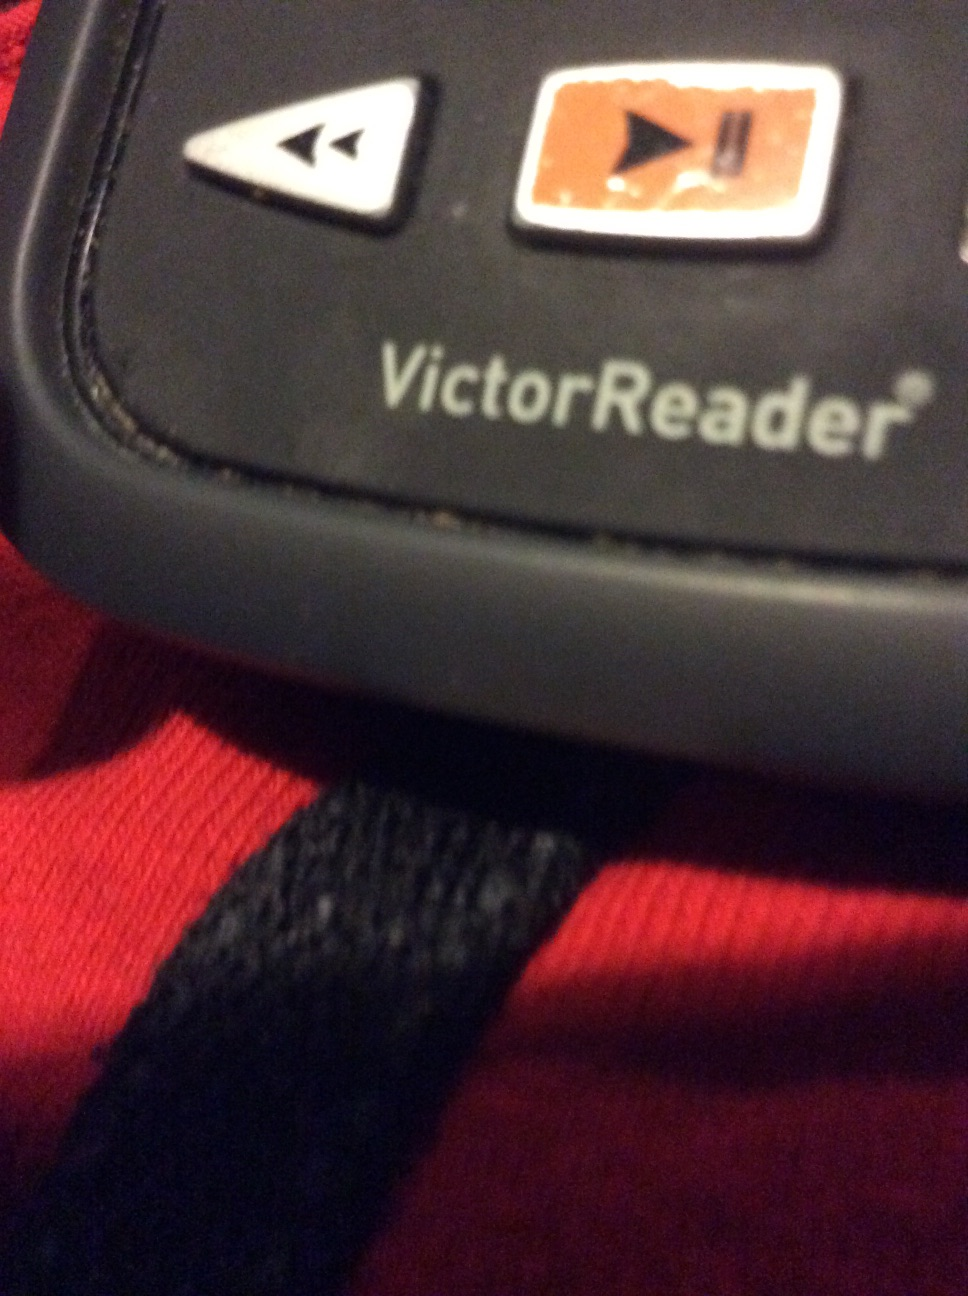Imagine a world where VictorReader devices are the norm, how would public spaces and libraries need to adapt? In a world where VictorReader devices are the norm, public spaces and libraries would undergo significant changes to ensure inclusivity and accessibility. Libraries would feature enhanced audio sections where users can easily download text-to-speech versions of all books. Public spaces like bus stations, airports, and museums would include audio navigation aids compatible with VictorReader, making it easier for visually impaired individuals to navigate and access information independently. Special zones with charging stations and VictorReader assistance desks would be commonplace, ensuring that help is always at hand. 